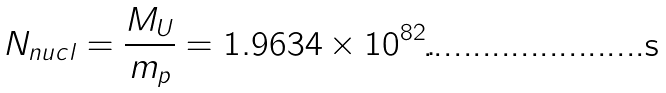Convert formula to latex. <formula><loc_0><loc_0><loc_500><loc_500>N _ { n u c l } = \frac { M _ { U } } { m _ { p } } = 1 . 9 6 3 4 \times 1 0 ^ { 8 2 } .</formula> 